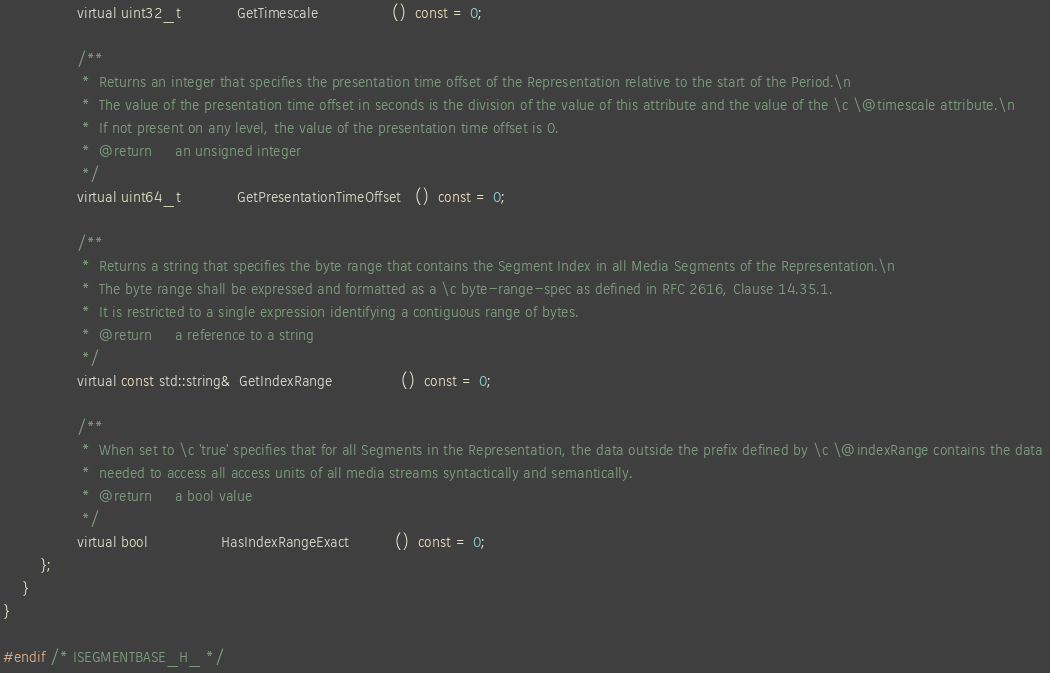Convert code to text. <code><loc_0><loc_0><loc_500><loc_500><_C_>                virtual uint32_t            GetTimescale                ()  const = 0;

                /**
                 *  Returns an integer that specifies the presentation time offset of the Representation relative to the start of the Period.\n
                 *  The value of the presentation time offset in seconds is the division of the value of this attribute and the value of the \c \@timescale attribute.\n
                 *  If not present on any level, the value of the presentation time offset is 0. 
                 *  @return     an unsigned integer
                 */
                virtual uint64_t            GetPresentationTimeOffset   ()  const = 0;

                /**
                 *  Returns a string that specifies the byte range that contains the Segment Index in all Media Segments of the Representation.\n
                 *  The byte range shall be expressed and formatted as a \c byte-range-spec as defined in RFC 2616, Clause 14.35.1. 
                 *  It is restricted to a single expression identifying a contiguous range of bytes.
                 *  @return     a reference to a string
                 */
                virtual const std::string&  GetIndexRange               ()  const = 0;

                /**
                 *  When set to \c 'true' specifies that for all Segments in the Representation, the data outside the prefix defined by \c \@indexRange contains the data 
                 *  needed to access all access units of all media streams syntactically and semantically.
                 *  @return     a bool value
                 */
                virtual bool                HasIndexRangeExact          ()  const = 0;
        };
    }
}

#endif /* ISEGMENTBASE_H_ */
</code> 